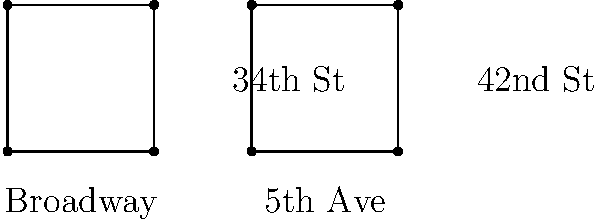Looking at this simplified map of two intersections in Manhattan, which shows Broadway and 34th Street, and 5th Avenue and 42nd Street, are these two intersections congruent shapes? Why or why not? To determine if the two intersections are congruent shapes, we need to follow these steps:

1. Identify the shapes: Both intersections form rectangles (or squares if the scale is 1:1).

2. Check the properties of congruence:
   a) Same shape: Both are rectangles, so this condition is met.
   b) Same size: We need to compare the side lengths.

3. Analyze the given information:
   - We don't have specific measurements, but we can see that the rectangles appear to be the same size visually.
   - In reality, NYC blocks are typically longer in the north-south direction than in the east-west direction.
   - However, for this simplified representation, we can assume they are drawn to scale.

4. Consider real-world knowledge:
   - As a NYC local, you might know that these intersections are not exactly the same size in reality.
   - Broadway is a diagonal street, which would typically create non-right angle intersections.

5. Conclusion:
   Based on the simplified representation in the diagram, the shapes appear congruent.
   However, in reality, these intersections would not be congruent due to the reasons mentioned above.

Therefore, for the purposes of this diagram, we can consider the shapes to be congruent, but it's important to note that this is a simplified representation and not an accurate depiction of the actual street layout.
Answer: Yes, in this simplified diagram. 